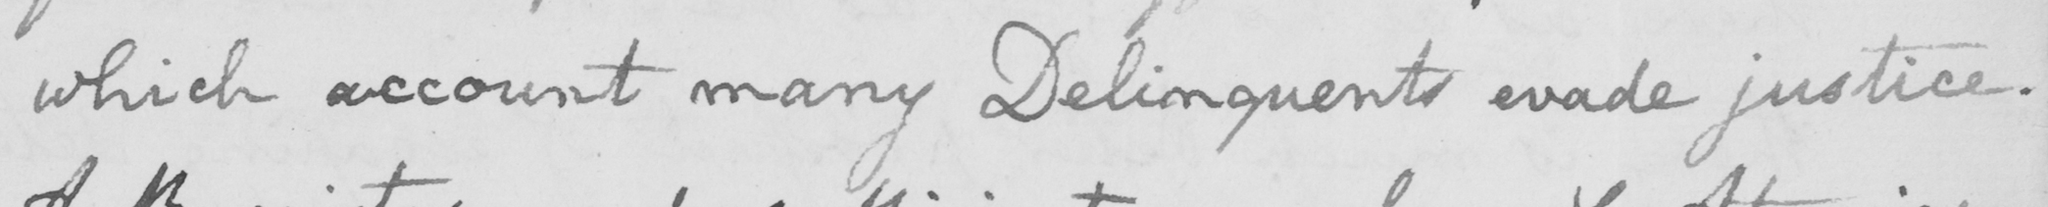Please provide the text content of this handwritten line. which account many Delinquents evade justice. 